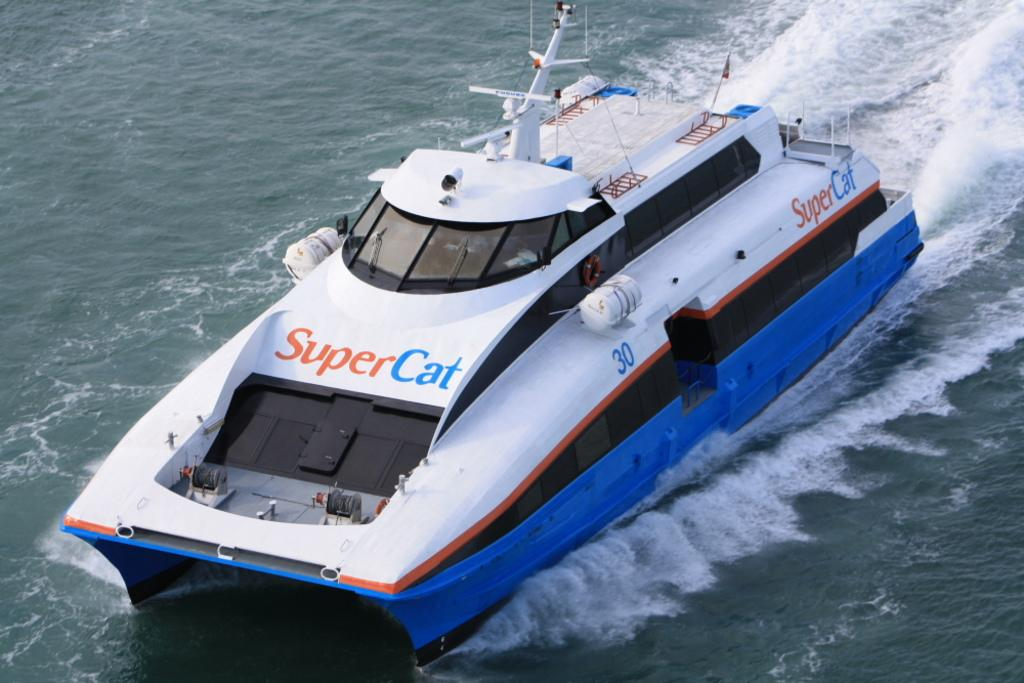<image>
Summarize the visual content of the image. a boat with the words Super Cat on it 